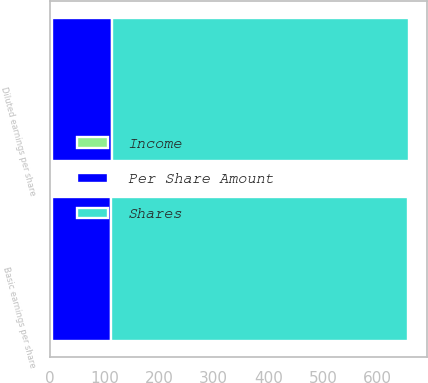<chart> <loc_0><loc_0><loc_500><loc_500><stacked_bar_chart><ecel><fcel>Basic earnings per share<fcel>Diluted earnings per share<nl><fcel>Shares<fcel>543.3<fcel>543.3<nl><fcel>Per Share Amount<fcel>107.4<fcel>109.1<nl><fcel>Income<fcel>5.06<fcel>4.98<nl></chart> 